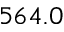<formula> <loc_0><loc_0><loc_500><loc_500>5 6 4 . 0</formula> 